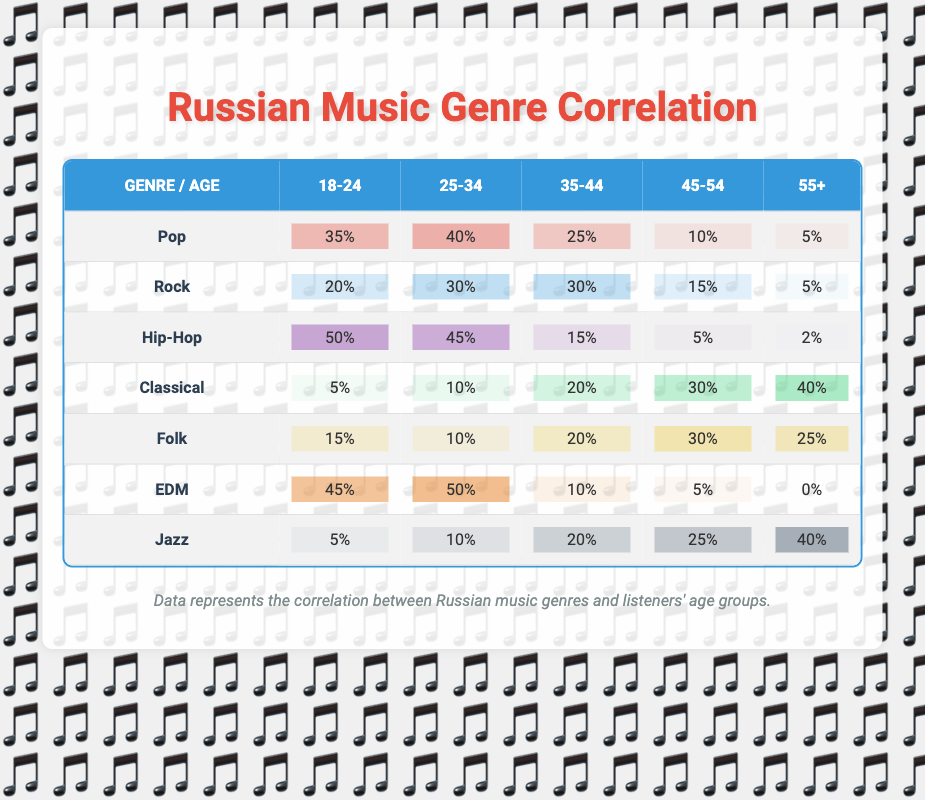What genre of music is most popular among the 18-24 age group? From the table, the percentage for each genre in the 18-24 age group can be compared directly. Hip-Hop has the highest percentage at 50%, followed by EDM at 45% and Pop at 35%.
Answer: Hip-Hop Which genre has the lowest listener percentage among the 55+ age group? Looking at the table for the 55+ age group percentages, EDM has 0%, which is lower than any other genre listed. Classical, for example, has 40%.
Answer: EDM What is the average percentage of listeners aged 35-44 across all genres? First, we add the percentages for the 35-44 age group: (25 + 30 + 15 + 20 + 20 + 10 + 20) = 130. Then we divide by the number of genres, which is 7, resulting in 130 / 7 = approximately 18.57.
Answer: 18.57 Is it true that more than half of the 25-34 age group prefers Pop? According to the table, Pop has a percentage of 40% for the 25-34 age group, which is less than half (50%). Therefore, this statement is false.
Answer: No What is the difference in Hip-Hop listeners between the ages of 18-24 and 45-54? The percentage for Hip-Hop in the 18-24 age group is 50%, and for 45-54, it is 5%. The difference is calculated by subtracting the two: 50% - 5% = 45%.
Answer: 45% What genre has the highest percentage difference between two specific age groups, and what is that difference? We will look for the largest difference in percentages across the age groups for the same genre. For Hip-Hop, the difference between 18-24 (50%) and 55+ (2%) is 48%. For EDM, it is 50% (25-34) and 0% (55+), totaling 50%. The highest difference is for EDM, which is 50%.
Answer: EDM, 50% Among the 35-44 age group, which genre has a higher listener percentage: Folk or Rock? Folk has 20%, while Rock has 30% among the 35-44 age group. Since 30% is greater than 20%, Rock is the genre with a higher listener percentage.
Answer: Rock What is the total percentage of listeners in the 45-54 age group across all genres? We add the percentages for the 45-54 age group: (10 + 15 + 5 + 30 + 30 + 5 + 25) = 100%. The total for all genres combined for this age group is therefore 100%.
Answer: 100% 